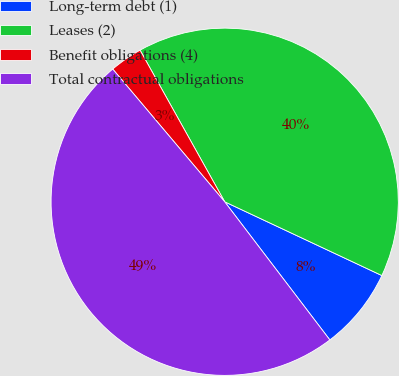Convert chart. <chart><loc_0><loc_0><loc_500><loc_500><pie_chart><fcel>Long-term debt (1)<fcel>Leases (2)<fcel>Benefit obligations (4)<fcel>Total contractual obligations<nl><fcel>7.66%<fcel>40.09%<fcel>3.05%<fcel>49.2%<nl></chart> 